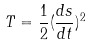<formula> <loc_0><loc_0><loc_500><loc_500>T = \frac { 1 } { 2 } ( \frac { d s } { d t } ) ^ { 2 }</formula> 